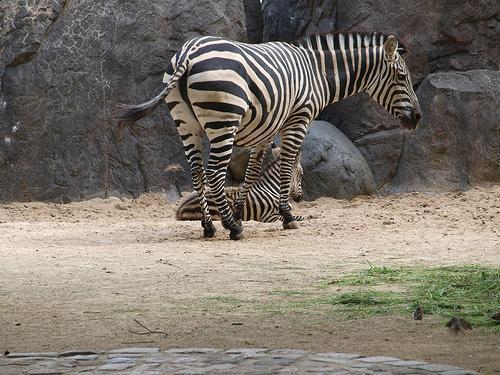How many zebras are in the image?
Give a very brief answer. 2. How many birds appear in the image?
Give a very brief answer. 2. How many legs does the adult zebra have?
Give a very brief answer. 4. 